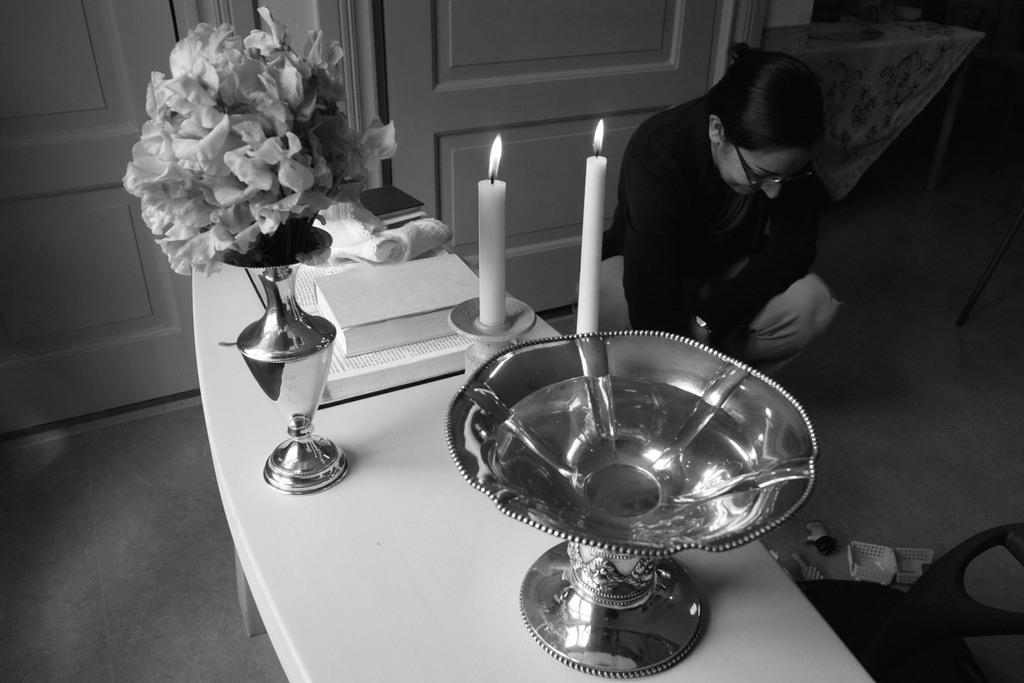What is in the bowl that is visible in the image? There is no information about the contents of the bowl in the provided facts. Besides the bowl, what other objects can be seen in the image? There is a flower vase, candles, books on the table, and a woman in the image. What type of furniture is present in the image? There is a chair in the image. Can you tell me how many impulses are being generated by the woman in the image? There is no information about impulses or any related measurements in the provided facts. Where is the playground located in the image? There is no playground present in the image. 